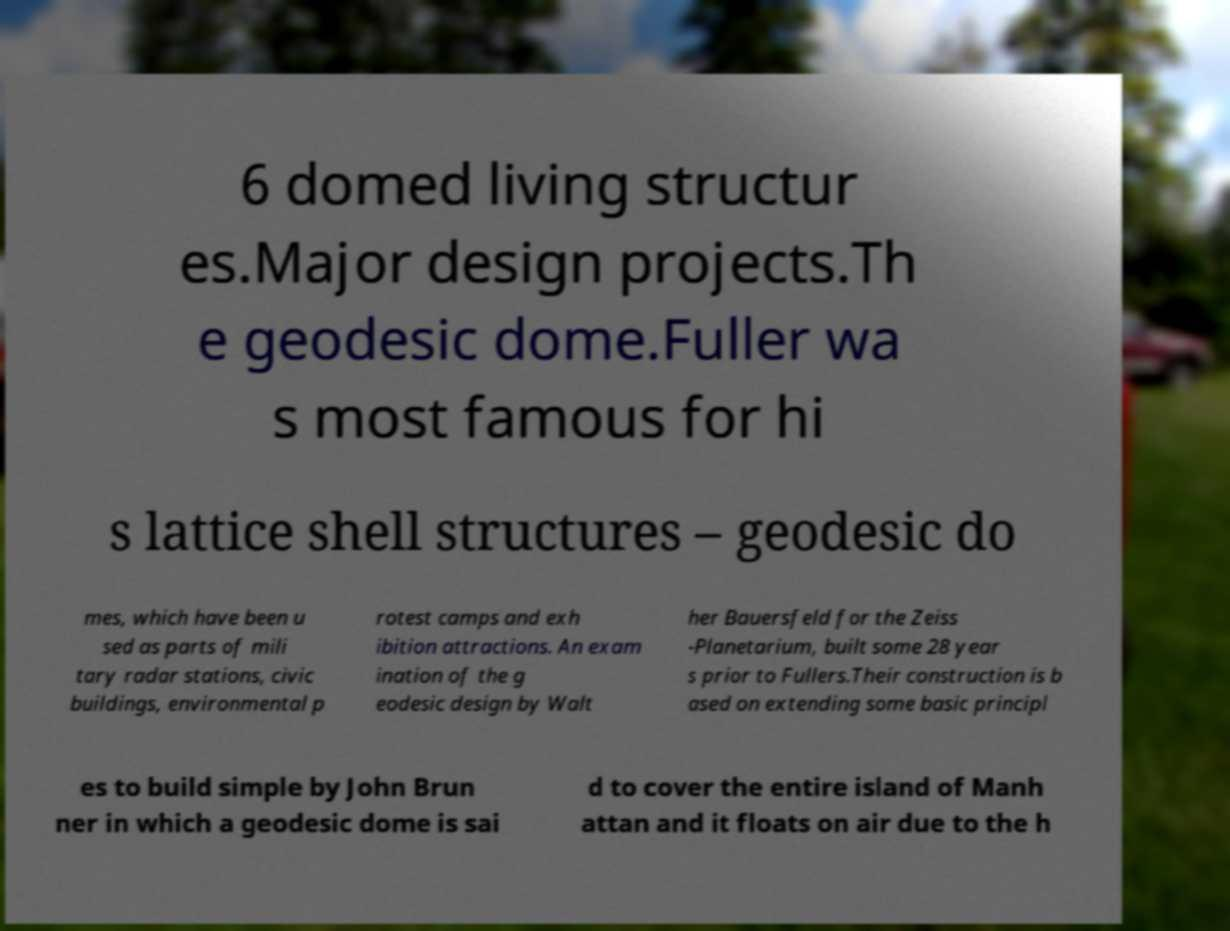Please identify and transcribe the text found in this image. 6 domed living structur es.Major design projects.Th e geodesic dome.Fuller wa s most famous for hi s lattice shell structures – geodesic do mes, which have been u sed as parts of mili tary radar stations, civic buildings, environmental p rotest camps and exh ibition attractions. An exam ination of the g eodesic design by Walt her Bauersfeld for the Zeiss -Planetarium, built some 28 year s prior to Fullers.Their construction is b ased on extending some basic principl es to build simple by John Brun ner in which a geodesic dome is sai d to cover the entire island of Manh attan and it floats on air due to the h 